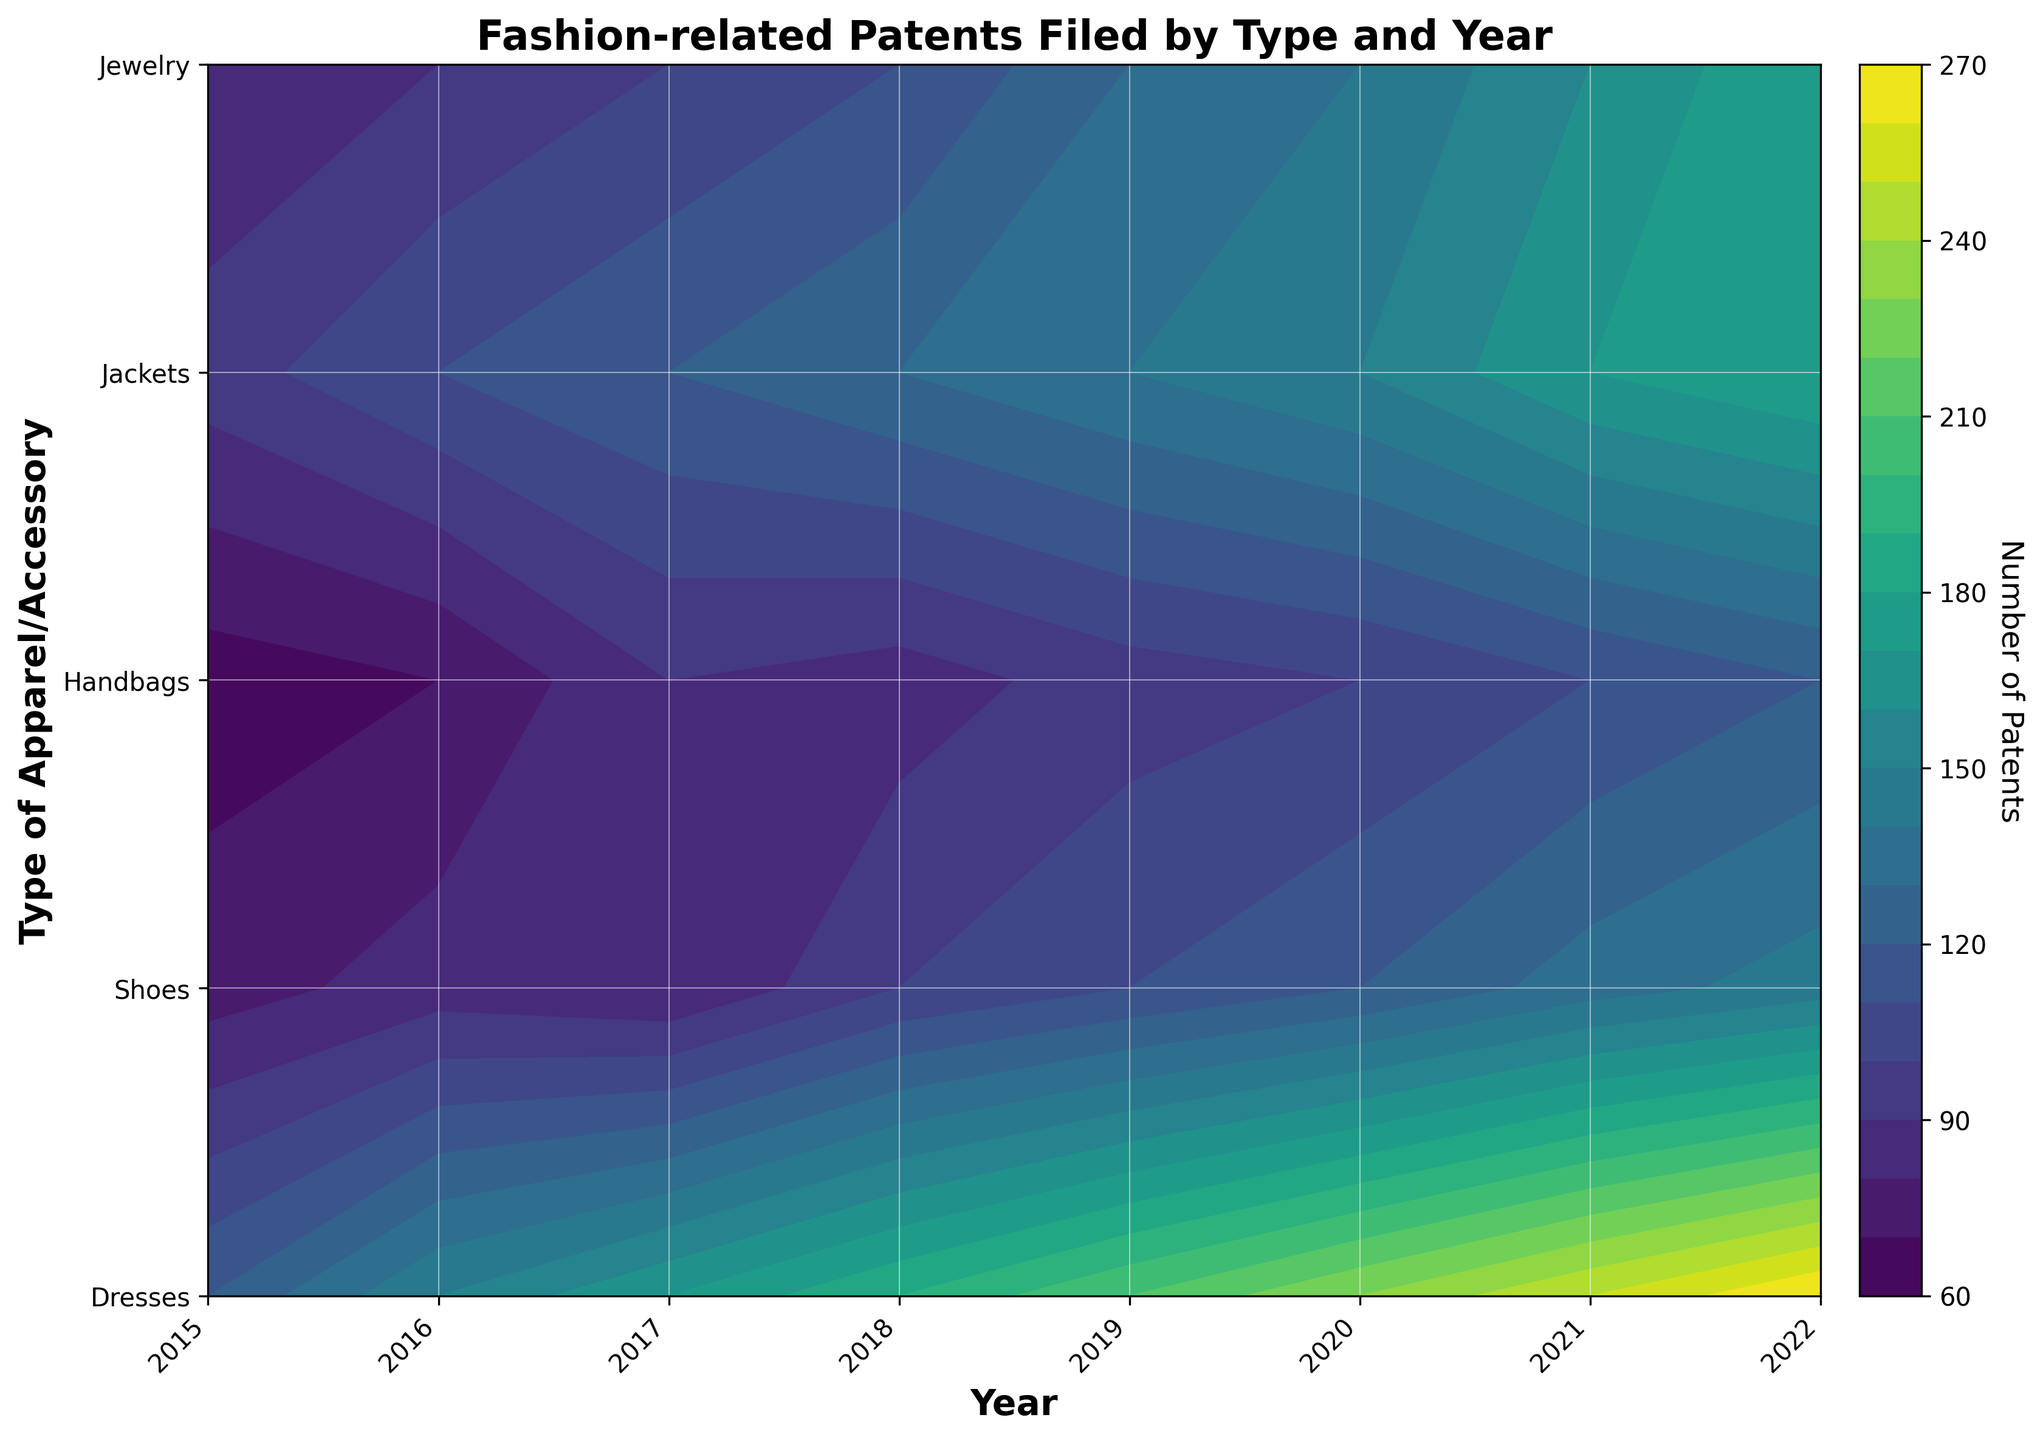what is the title of the chart? Look at the top of the chart; the title is typically found there.
Answer: Fashion-related Patents Filed by Type and Year how many types of apparel/accessory are shown in the plot? The y-axis labels indicate the different types of apparel and accessories shown. Count these labels.
Answer: 5 which year had the highest number of patents filed for 'Dresses'? Locate 'Dresses' on the y-axis and look for the highest contour level across the years on the x-axis.
Answer: 2022 between 'Handbags' and 'Jackets,' which had more patents filed in 2019? Compare the contour levels for 'Handbags' and 'Jackets' in 2019 on the x-axis.
Answer: Handbags on average, does the number of patents filed for 'Jewelry' increase or decrease from 2015 to 2022? Look at the contour levels for 'Jewelry' from 2015 to 2022 and observe if the levels generally increase or decrease over time.
Answer: Increase in which year did 'Shoes' see the largest increase in patents filed compared to the previous year? Compare the contour levels for 'Shoes' between consecutive years and identify the largest jump.
Answer: 2021 what is the overall trend in the number of fashion-related patents filed from 2015 to 2022? Observe the color gradient and contour levels across all years and types to determine the overall trend.
Answer: Increasing does any type of apparel/accessory show a consistent trend over the years? If yes, which one and what is the trend? Check the contour levels for each type of apparel/accessory and see if any show a consistent pattern.
Answer: Dresses, Increasing which type of apparel/accessory had the fewest patents filed overall in 2015? Compare the contour levels for all types in 2015 and find the lowest one.
Answer: Jackets did any type of apparel/accessory have the same number of patents filed for two or more consecutive years? If yes, which type and years? For each type of apparel/accessory, check if the contour levels stay the same for any couple of consecutive years.
Answer: No 